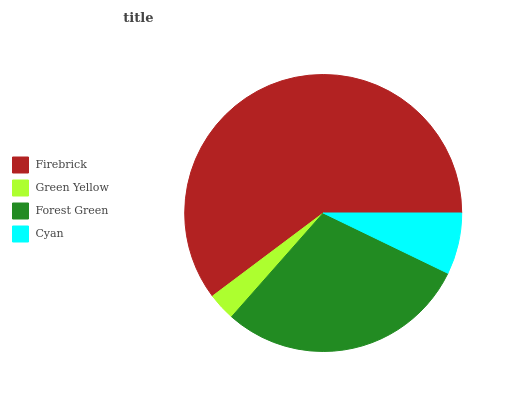Is Green Yellow the minimum?
Answer yes or no. Yes. Is Firebrick the maximum?
Answer yes or no. Yes. Is Forest Green the minimum?
Answer yes or no. No. Is Forest Green the maximum?
Answer yes or no. No. Is Forest Green greater than Green Yellow?
Answer yes or no. Yes. Is Green Yellow less than Forest Green?
Answer yes or no. Yes. Is Green Yellow greater than Forest Green?
Answer yes or no. No. Is Forest Green less than Green Yellow?
Answer yes or no. No. Is Forest Green the high median?
Answer yes or no. Yes. Is Cyan the low median?
Answer yes or no. Yes. Is Green Yellow the high median?
Answer yes or no. No. Is Firebrick the low median?
Answer yes or no. No. 